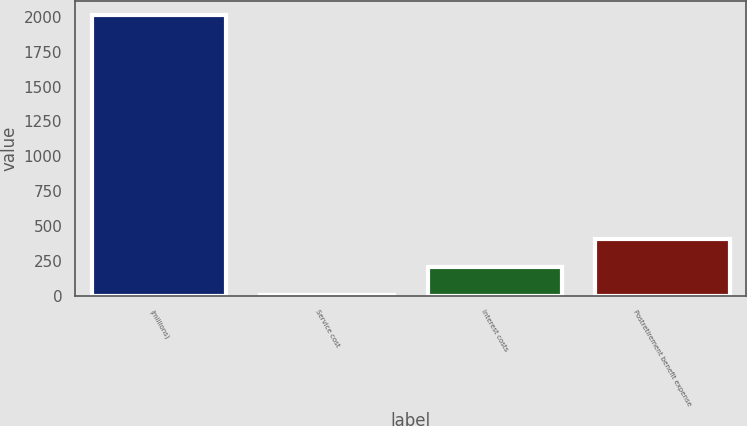Convert chart to OTSL. <chart><loc_0><loc_0><loc_500><loc_500><bar_chart><fcel>(millions)<fcel>Service cost<fcel>Interest costs<fcel>Postretirement benefit expense<nl><fcel>2016<fcel>2.7<fcel>204.03<fcel>405.36<nl></chart> 